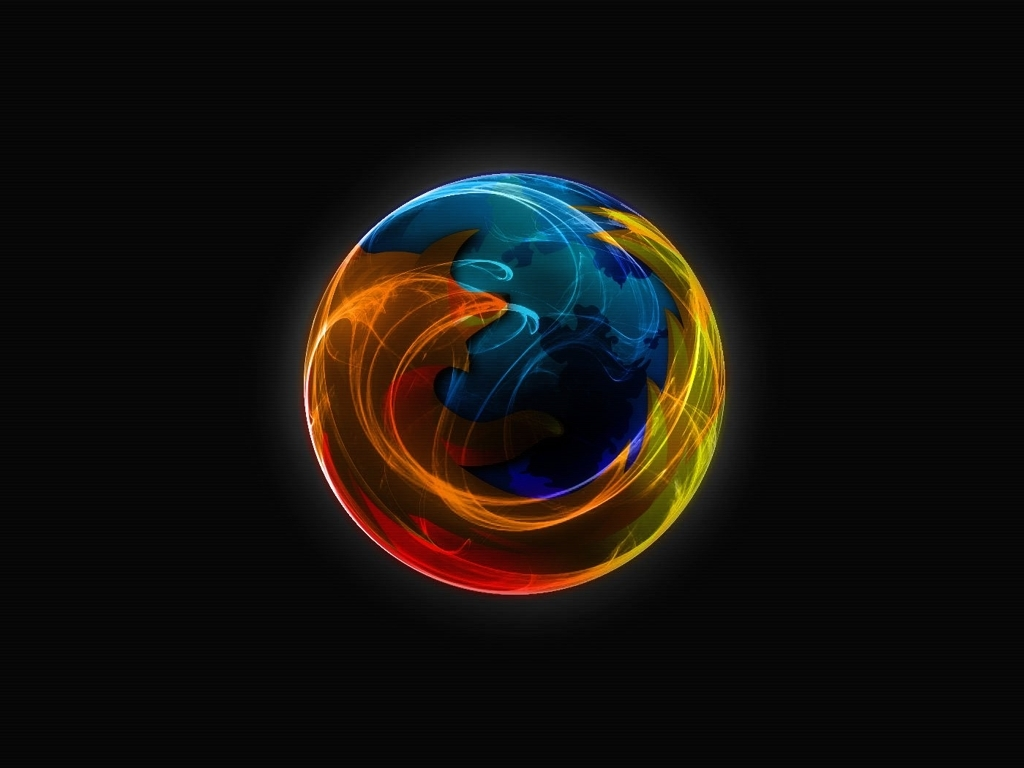What emotions does this image evoke? This image evokes a sense of energy and intensity, with the swirls of warm and cool colors creating a dynamic contrast that could be interpreted as a metaphor for creativity, passion, or even turmoil. 